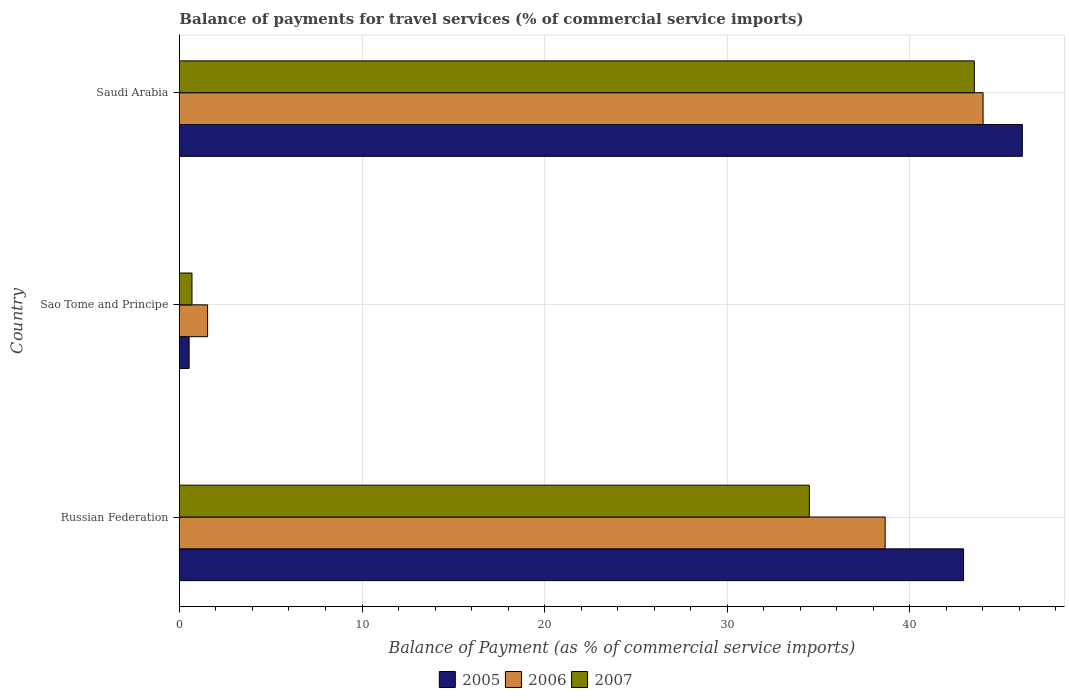Are the number of bars on each tick of the Y-axis equal?
Offer a terse response. Yes. How many bars are there on the 1st tick from the top?
Keep it short and to the point. 3. How many bars are there on the 3rd tick from the bottom?
Give a very brief answer. 3. What is the label of the 2nd group of bars from the top?
Ensure brevity in your answer.  Sao Tome and Principe. In how many cases, is the number of bars for a given country not equal to the number of legend labels?
Offer a terse response. 0. What is the balance of payments for travel services in 2005 in Russian Federation?
Make the answer very short. 42.94. Across all countries, what is the maximum balance of payments for travel services in 2005?
Keep it short and to the point. 46.16. Across all countries, what is the minimum balance of payments for travel services in 2006?
Give a very brief answer. 1.54. In which country was the balance of payments for travel services in 2006 maximum?
Provide a short and direct response. Saudi Arabia. In which country was the balance of payments for travel services in 2005 minimum?
Make the answer very short. Sao Tome and Principe. What is the total balance of payments for travel services in 2005 in the graph?
Provide a succinct answer. 89.64. What is the difference between the balance of payments for travel services in 2006 in Russian Federation and that in Sao Tome and Principe?
Provide a succinct answer. 37.11. What is the difference between the balance of payments for travel services in 2005 in Russian Federation and the balance of payments for travel services in 2007 in Sao Tome and Principe?
Keep it short and to the point. 42.26. What is the average balance of payments for travel services in 2007 per country?
Ensure brevity in your answer.  26.24. What is the difference between the balance of payments for travel services in 2005 and balance of payments for travel services in 2006 in Saudi Arabia?
Your answer should be compact. 2.15. What is the ratio of the balance of payments for travel services in 2007 in Russian Federation to that in Sao Tome and Principe?
Give a very brief answer. 50.13. What is the difference between the highest and the second highest balance of payments for travel services in 2005?
Provide a short and direct response. 3.22. What is the difference between the highest and the lowest balance of payments for travel services in 2005?
Offer a very short reply. 45.63. In how many countries, is the balance of payments for travel services in 2006 greater than the average balance of payments for travel services in 2006 taken over all countries?
Keep it short and to the point. 2. What does the 2nd bar from the top in Sao Tome and Principe represents?
Provide a succinct answer. 2006. Is it the case that in every country, the sum of the balance of payments for travel services in 2007 and balance of payments for travel services in 2005 is greater than the balance of payments for travel services in 2006?
Keep it short and to the point. No. Are all the bars in the graph horizontal?
Your answer should be compact. Yes. How many countries are there in the graph?
Your response must be concise. 3. What is the difference between two consecutive major ticks on the X-axis?
Offer a terse response. 10. How many legend labels are there?
Your response must be concise. 3. How are the legend labels stacked?
Provide a succinct answer. Horizontal. What is the title of the graph?
Ensure brevity in your answer.  Balance of payments for travel services (% of commercial service imports). What is the label or title of the X-axis?
Provide a succinct answer. Balance of Payment (as % of commercial service imports). What is the Balance of Payment (as % of commercial service imports) in 2005 in Russian Federation?
Your answer should be compact. 42.94. What is the Balance of Payment (as % of commercial service imports) of 2006 in Russian Federation?
Make the answer very short. 38.65. What is the Balance of Payment (as % of commercial service imports) in 2007 in Russian Federation?
Keep it short and to the point. 34.5. What is the Balance of Payment (as % of commercial service imports) of 2005 in Sao Tome and Principe?
Provide a succinct answer. 0.53. What is the Balance of Payment (as % of commercial service imports) in 2006 in Sao Tome and Principe?
Keep it short and to the point. 1.54. What is the Balance of Payment (as % of commercial service imports) in 2007 in Sao Tome and Principe?
Your answer should be compact. 0.69. What is the Balance of Payment (as % of commercial service imports) in 2005 in Saudi Arabia?
Provide a short and direct response. 46.16. What is the Balance of Payment (as % of commercial service imports) of 2006 in Saudi Arabia?
Provide a succinct answer. 44.01. What is the Balance of Payment (as % of commercial service imports) of 2007 in Saudi Arabia?
Give a very brief answer. 43.53. Across all countries, what is the maximum Balance of Payment (as % of commercial service imports) of 2005?
Provide a succinct answer. 46.16. Across all countries, what is the maximum Balance of Payment (as % of commercial service imports) in 2006?
Your answer should be very brief. 44.01. Across all countries, what is the maximum Balance of Payment (as % of commercial service imports) in 2007?
Keep it short and to the point. 43.53. Across all countries, what is the minimum Balance of Payment (as % of commercial service imports) in 2005?
Give a very brief answer. 0.53. Across all countries, what is the minimum Balance of Payment (as % of commercial service imports) in 2006?
Offer a terse response. 1.54. Across all countries, what is the minimum Balance of Payment (as % of commercial service imports) in 2007?
Provide a succinct answer. 0.69. What is the total Balance of Payment (as % of commercial service imports) in 2005 in the graph?
Provide a succinct answer. 89.64. What is the total Balance of Payment (as % of commercial service imports) of 2006 in the graph?
Keep it short and to the point. 84.21. What is the total Balance of Payment (as % of commercial service imports) in 2007 in the graph?
Offer a terse response. 78.72. What is the difference between the Balance of Payment (as % of commercial service imports) of 2005 in Russian Federation and that in Sao Tome and Principe?
Your answer should be very brief. 42.41. What is the difference between the Balance of Payment (as % of commercial service imports) of 2006 in Russian Federation and that in Sao Tome and Principe?
Your answer should be compact. 37.11. What is the difference between the Balance of Payment (as % of commercial service imports) in 2007 in Russian Federation and that in Sao Tome and Principe?
Provide a succinct answer. 33.81. What is the difference between the Balance of Payment (as % of commercial service imports) in 2005 in Russian Federation and that in Saudi Arabia?
Make the answer very short. -3.22. What is the difference between the Balance of Payment (as % of commercial service imports) of 2006 in Russian Federation and that in Saudi Arabia?
Ensure brevity in your answer.  -5.36. What is the difference between the Balance of Payment (as % of commercial service imports) in 2007 in Russian Federation and that in Saudi Arabia?
Your answer should be compact. -9.03. What is the difference between the Balance of Payment (as % of commercial service imports) in 2005 in Sao Tome and Principe and that in Saudi Arabia?
Provide a short and direct response. -45.63. What is the difference between the Balance of Payment (as % of commercial service imports) of 2006 in Sao Tome and Principe and that in Saudi Arabia?
Give a very brief answer. -42.47. What is the difference between the Balance of Payment (as % of commercial service imports) of 2007 in Sao Tome and Principe and that in Saudi Arabia?
Your response must be concise. -42.85. What is the difference between the Balance of Payment (as % of commercial service imports) of 2005 in Russian Federation and the Balance of Payment (as % of commercial service imports) of 2006 in Sao Tome and Principe?
Provide a succinct answer. 41.4. What is the difference between the Balance of Payment (as % of commercial service imports) in 2005 in Russian Federation and the Balance of Payment (as % of commercial service imports) in 2007 in Sao Tome and Principe?
Your response must be concise. 42.26. What is the difference between the Balance of Payment (as % of commercial service imports) in 2006 in Russian Federation and the Balance of Payment (as % of commercial service imports) in 2007 in Sao Tome and Principe?
Your answer should be compact. 37.96. What is the difference between the Balance of Payment (as % of commercial service imports) in 2005 in Russian Federation and the Balance of Payment (as % of commercial service imports) in 2006 in Saudi Arabia?
Provide a short and direct response. -1.07. What is the difference between the Balance of Payment (as % of commercial service imports) of 2005 in Russian Federation and the Balance of Payment (as % of commercial service imports) of 2007 in Saudi Arabia?
Make the answer very short. -0.59. What is the difference between the Balance of Payment (as % of commercial service imports) in 2006 in Russian Federation and the Balance of Payment (as % of commercial service imports) in 2007 in Saudi Arabia?
Offer a terse response. -4.88. What is the difference between the Balance of Payment (as % of commercial service imports) of 2005 in Sao Tome and Principe and the Balance of Payment (as % of commercial service imports) of 2006 in Saudi Arabia?
Provide a succinct answer. -43.48. What is the difference between the Balance of Payment (as % of commercial service imports) in 2005 in Sao Tome and Principe and the Balance of Payment (as % of commercial service imports) in 2007 in Saudi Arabia?
Offer a terse response. -43. What is the difference between the Balance of Payment (as % of commercial service imports) in 2006 in Sao Tome and Principe and the Balance of Payment (as % of commercial service imports) in 2007 in Saudi Arabia?
Provide a short and direct response. -41.99. What is the average Balance of Payment (as % of commercial service imports) in 2005 per country?
Offer a terse response. 29.88. What is the average Balance of Payment (as % of commercial service imports) in 2006 per country?
Provide a short and direct response. 28.07. What is the average Balance of Payment (as % of commercial service imports) of 2007 per country?
Provide a short and direct response. 26.24. What is the difference between the Balance of Payment (as % of commercial service imports) in 2005 and Balance of Payment (as % of commercial service imports) in 2006 in Russian Federation?
Provide a succinct answer. 4.29. What is the difference between the Balance of Payment (as % of commercial service imports) in 2005 and Balance of Payment (as % of commercial service imports) in 2007 in Russian Federation?
Ensure brevity in your answer.  8.44. What is the difference between the Balance of Payment (as % of commercial service imports) of 2006 and Balance of Payment (as % of commercial service imports) of 2007 in Russian Federation?
Offer a very short reply. 4.15. What is the difference between the Balance of Payment (as % of commercial service imports) of 2005 and Balance of Payment (as % of commercial service imports) of 2006 in Sao Tome and Principe?
Your answer should be very brief. -1.01. What is the difference between the Balance of Payment (as % of commercial service imports) of 2005 and Balance of Payment (as % of commercial service imports) of 2007 in Sao Tome and Principe?
Provide a succinct answer. -0.16. What is the difference between the Balance of Payment (as % of commercial service imports) of 2006 and Balance of Payment (as % of commercial service imports) of 2007 in Sao Tome and Principe?
Provide a succinct answer. 0.86. What is the difference between the Balance of Payment (as % of commercial service imports) in 2005 and Balance of Payment (as % of commercial service imports) in 2006 in Saudi Arabia?
Provide a succinct answer. 2.15. What is the difference between the Balance of Payment (as % of commercial service imports) of 2005 and Balance of Payment (as % of commercial service imports) of 2007 in Saudi Arabia?
Your response must be concise. 2.63. What is the difference between the Balance of Payment (as % of commercial service imports) of 2006 and Balance of Payment (as % of commercial service imports) of 2007 in Saudi Arabia?
Keep it short and to the point. 0.48. What is the ratio of the Balance of Payment (as % of commercial service imports) of 2005 in Russian Federation to that in Sao Tome and Principe?
Keep it short and to the point. 80.75. What is the ratio of the Balance of Payment (as % of commercial service imports) in 2006 in Russian Federation to that in Sao Tome and Principe?
Provide a short and direct response. 25.04. What is the ratio of the Balance of Payment (as % of commercial service imports) of 2007 in Russian Federation to that in Sao Tome and Principe?
Keep it short and to the point. 50.13. What is the ratio of the Balance of Payment (as % of commercial service imports) in 2005 in Russian Federation to that in Saudi Arabia?
Provide a short and direct response. 0.93. What is the ratio of the Balance of Payment (as % of commercial service imports) in 2006 in Russian Federation to that in Saudi Arabia?
Give a very brief answer. 0.88. What is the ratio of the Balance of Payment (as % of commercial service imports) of 2007 in Russian Federation to that in Saudi Arabia?
Your answer should be very brief. 0.79. What is the ratio of the Balance of Payment (as % of commercial service imports) of 2005 in Sao Tome and Principe to that in Saudi Arabia?
Give a very brief answer. 0.01. What is the ratio of the Balance of Payment (as % of commercial service imports) in 2006 in Sao Tome and Principe to that in Saudi Arabia?
Your response must be concise. 0.04. What is the ratio of the Balance of Payment (as % of commercial service imports) of 2007 in Sao Tome and Principe to that in Saudi Arabia?
Your answer should be compact. 0.02. What is the difference between the highest and the second highest Balance of Payment (as % of commercial service imports) of 2005?
Give a very brief answer. 3.22. What is the difference between the highest and the second highest Balance of Payment (as % of commercial service imports) in 2006?
Your response must be concise. 5.36. What is the difference between the highest and the second highest Balance of Payment (as % of commercial service imports) in 2007?
Provide a short and direct response. 9.03. What is the difference between the highest and the lowest Balance of Payment (as % of commercial service imports) in 2005?
Provide a short and direct response. 45.63. What is the difference between the highest and the lowest Balance of Payment (as % of commercial service imports) of 2006?
Give a very brief answer. 42.47. What is the difference between the highest and the lowest Balance of Payment (as % of commercial service imports) of 2007?
Keep it short and to the point. 42.85. 